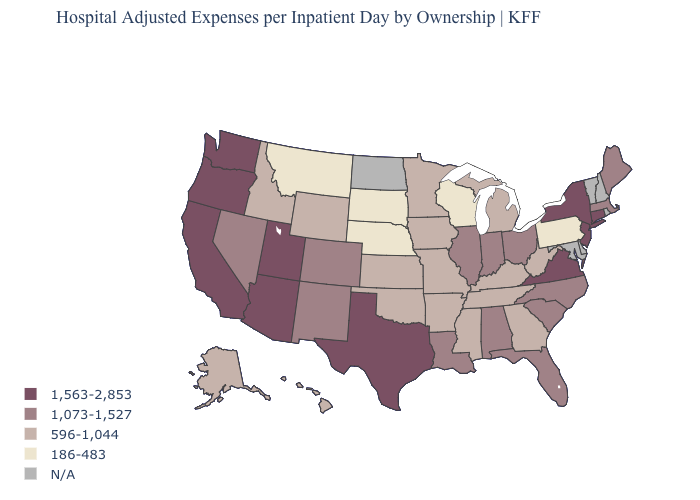Name the states that have a value in the range 1,073-1,527?
Write a very short answer. Alabama, Colorado, Florida, Illinois, Indiana, Louisiana, Maine, Massachusetts, Nevada, New Mexico, North Carolina, Ohio, South Carolina. Is the legend a continuous bar?
Keep it brief. No. Which states have the lowest value in the USA?
Answer briefly. Montana, Nebraska, Pennsylvania, South Dakota, Wisconsin. Name the states that have a value in the range N/A?
Write a very short answer. Delaware, Maryland, New Hampshire, North Dakota, Rhode Island, Vermont. What is the value of Nebraska?
Keep it brief. 186-483. Which states have the lowest value in the Northeast?
Quick response, please. Pennsylvania. Name the states that have a value in the range 1,563-2,853?
Short answer required. Arizona, California, Connecticut, New Jersey, New York, Oregon, Texas, Utah, Virginia, Washington. What is the value of Washington?
Be succinct. 1,563-2,853. How many symbols are there in the legend?
Give a very brief answer. 5. Name the states that have a value in the range 596-1,044?
Write a very short answer. Alaska, Arkansas, Georgia, Hawaii, Idaho, Iowa, Kansas, Kentucky, Michigan, Minnesota, Mississippi, Missouri, Oklahoma, Tennessee, West Virginia, Wyoming. Name the states that have a value in the range 186-483?
Quick response, please. Montana, Nebraska, Pennsylvania, South Dakota, Wisconsin. Which states have the highest value in the USA?
Short answer required. Arizona, California, Connecticut, New Jersey, New York, Oregon, Texas, Utah, Virginia, Washington. Does the first symbol in the legend represent the smallest category?
Keep it brief. No. What is the highest value in the USA?
Write a very short answer. 1,563-2,853. 